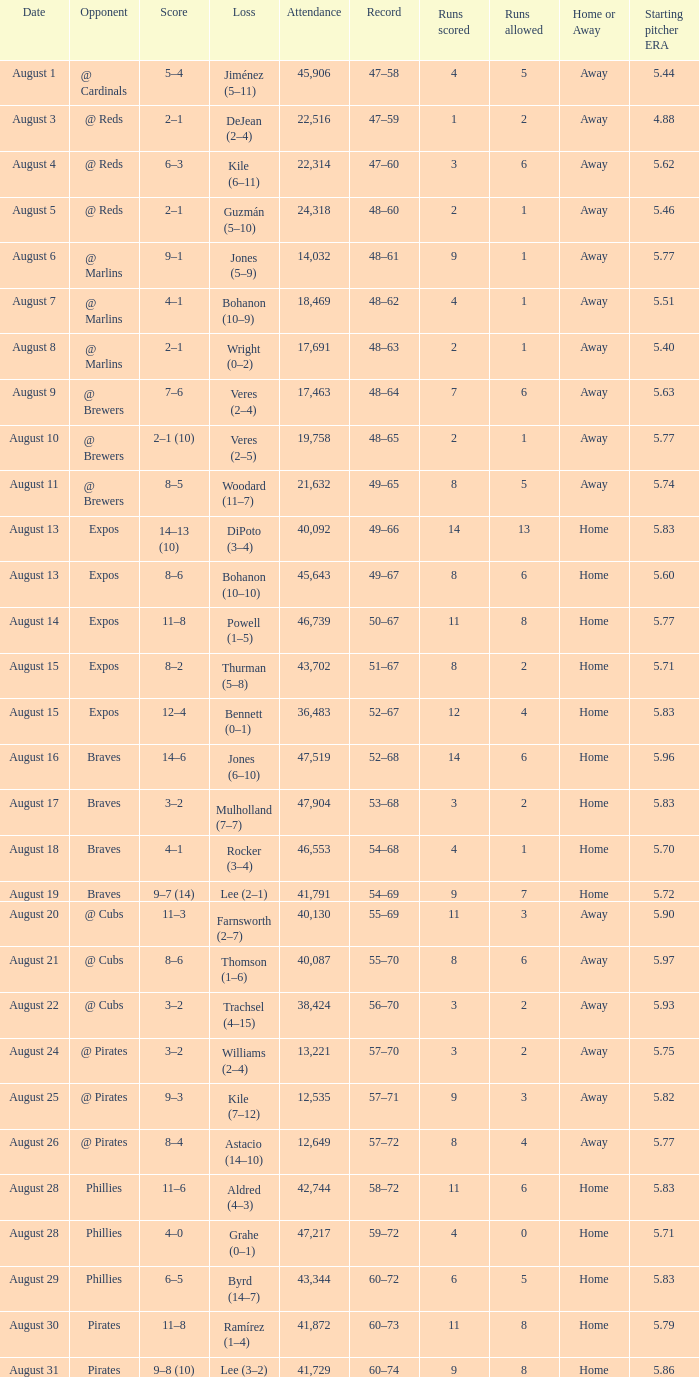What is the lowest attendance total on August 26? 12649.0. 